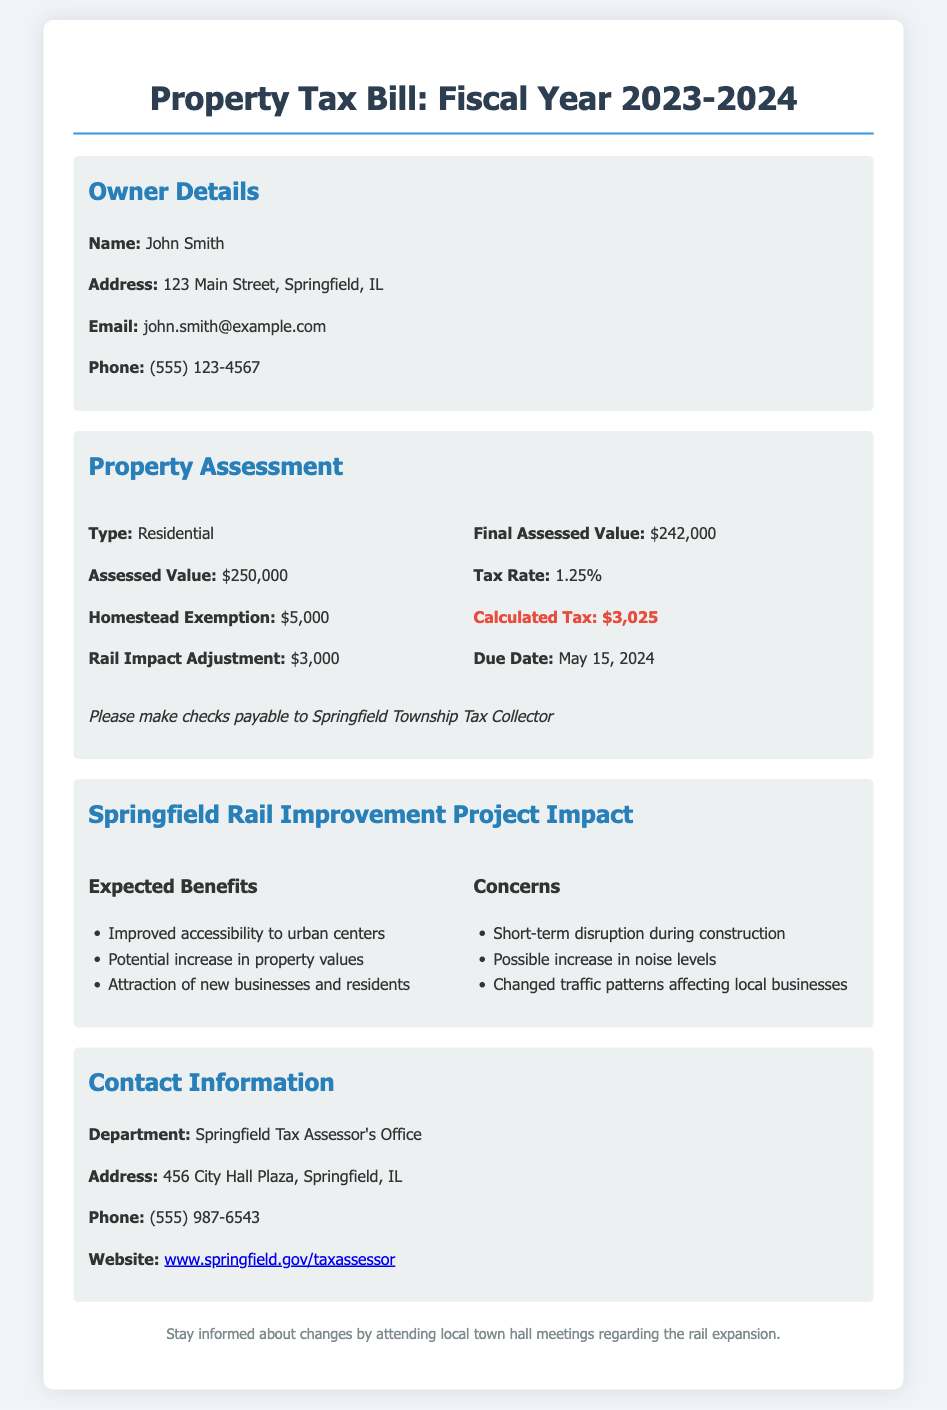What is the owner's name? The owner's name is listed under Owner Details in the document.
Answer: John Smith What is the assessed value of the property? The assessed value can be found in the Property Assessment section of the document.
Answer: $250,000 What is the tax rate for the property? The tax rate is specified in the Property Assessment section.
Answer: 1.25% What is the calculated tax amount? The calculated tax amount is provided in the Property Assessment section.
Answer: $3,025 What is the due date for the property tax? The due date is mentioned in the Property Assessment section of the document.
Answer: May 15, 2024 What adjustment is made for rail impact? The rail impact adjustment is specified in the Property Assessment section.
Answer: $3,000 What are the expected benefits mentioned in the rail project impact? The expected benefits can be found in the Springfield Rail Improvement Project Impact section.
Answer: Improved accessibility to urban centers What potential concern is listed regarding the rail project? The concerns about the rail project are detailed in the Springfield Rail Improvement Project Impact section.
Answer: Possible increase in noise levels Where is the Springfield Tax Assessor's Office located? The location can be found in the Contact Information section of the document.
Answer: 456 City Hall Plaza, Springfield, IL 